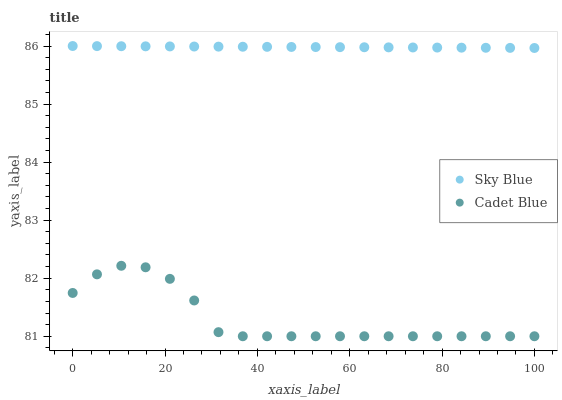Does Cadet Blue have the minimum area under the curve?
Answer yes or no. Yes. Does Sky Blue have the maximum area under the curve?
Answer yes or no. Yes. Does Cadet Blue have the maximum area under the curve?
Answer yes or no. No. Is Sky Blue the smoothest?
Answer yes or no. Yes. Is Cadet Blue the roughest?
Answer yes or no. Yes. Is Cadet Blue the smoothest?
Answer yes or no. No. Does Cadet Blue have the lowest value?
Answer yes or no. Yes. Does Sky Blue have the highest value?
Answer yes or no. Yes. Does Cadet Blue have the highest value?
Answer yes or no. No. Is Cadet Blue less than Sky Blue?
Answer yes or no. Yes. Is Sky Blue greater than Cadet Blue?
Answer yes or no. Yes. Does Cadet Blue intersect Sky Blue?
Answer yes or no. No. 